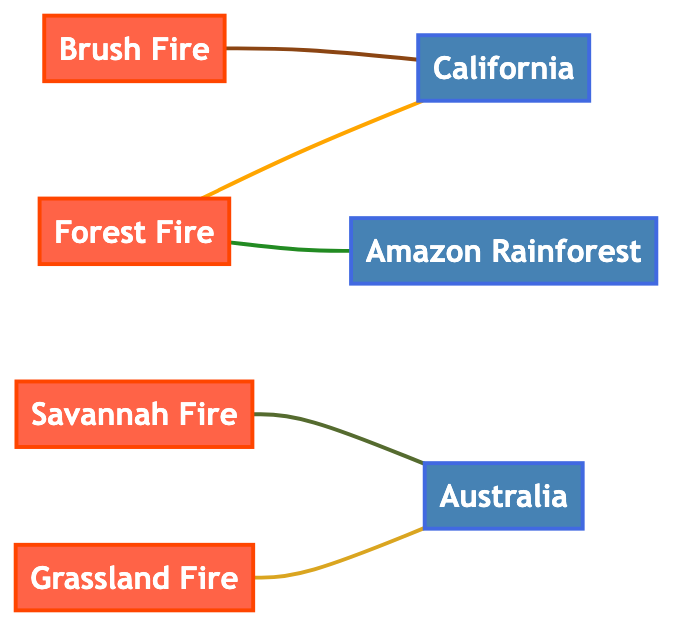What types of wildfires are represented in the diagram? The diagram contains nodes representing four types of wildfires: Forest Fire, Grassland Fire, Brush Fire, and Savannah Fire.
Answer: Forest Fire, Grassland Fire, Brush Fire, Savannah Fire How many regions are shown in the diagram? There are three regions indicated in the diagram: California, Australia, and Amazon Rainforest.
Answer: 3 What type of wildfire is linked to California? The diagram reveals that both Forest Fire and Brush Fire are linked to the region of California.
Answer: Forest Fire, Brush Fire Which fire type is associated with Australia? The Grassland Fire and Savannah Fire both have connections to Australia as per the diagram.
Answer: Grassland Fire, Savannah Fire What causes seasonal forest fires in California according to the graph? The graph indicates that seasonal forest fires in California are caused by a dry climate and human activities, as represented by the edge connecting them.
Answer: Dry climate and human activities How many edges connect to the Amazon Rainforest? The Amazon Rainforest is connected by two edges, one from Forest Fire and the other representing its relationship with a region.
Answer: 2 Which wildfire type has the strongest association with human activity in California? The Brush Fire in California is noted specifically for spreading from wildland areas into urban interfaces, indicating a strong association with human activity.
Answer: Brush Fire What is the relationship between Savannah Fire and Australia? The diagram shows that Savannah Fire occurs naturally within Australia's ecosystems, indicating a natural relationship between them.
Answer: Natural part of the ecosystem What is the main reason for intense forest fires in the Amazon Rainforest? The graph specifies that the intense forest fires in the Amazon are primarily due to deforestation and dry conditions, as illustrated by the edge connecting them.
Answer: Deforestation and dry conditions 